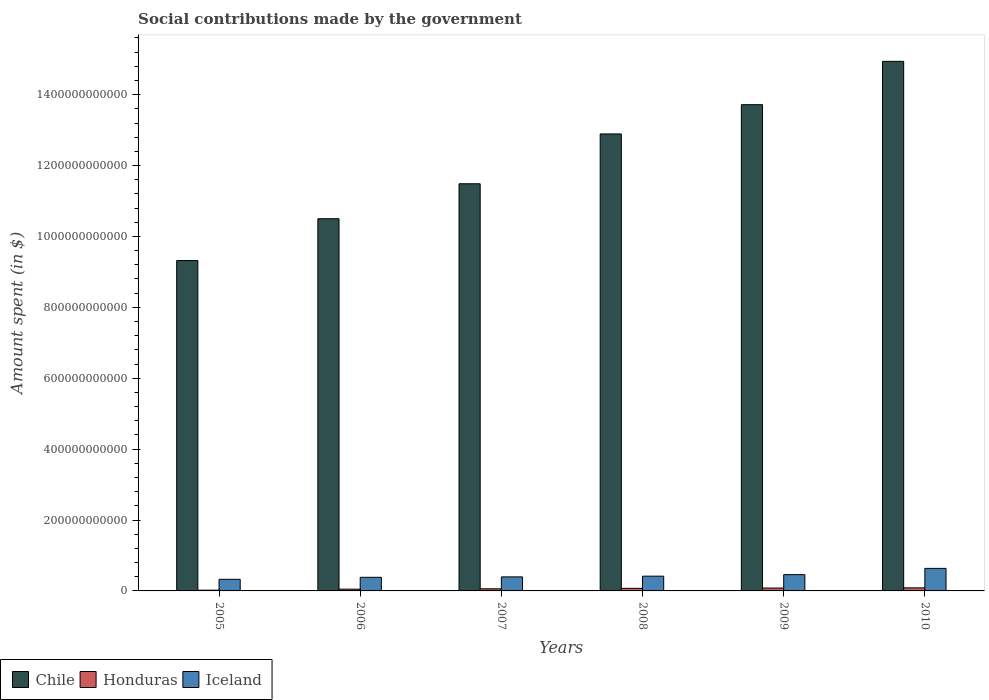How many different coloured bars are there?
Your answer should be very brief. 3. Are the number of bars per tick equal to the number of legend labels?
Provide a succinct answer. Yes. Are the number of bars on each tick of the X-axis equal?
Your answer should be very brief. Yes. How many bars are there on the 3rd tick from the left?
Keep it short and to the point. 3. In how many cases, is the number of bars for a given year not equal to the number of legend labels?
Provide a succinct answer. 0. What is the amount spent on social contributions in Honduras in 2005?
Give a very brief answer. 2.13e+09. Across all years, what is the maximum amount spent on social contributions in Honduras?
Your answer should be compact. 8.67e+09. Across all years, what is the minimum amount spent on social contributions in Iceland?
Provide a short and direct response. 3.28e+1. What is the total amount spent on social contributions in Iceland in the graph?
Provide a short and direct response. 2.62e+11. What is the difference between the amount spent on social contributions in Iceland in 2008 and that in 2010?
Make the answer very short. -2.20e+1. What is the difference between the amount spent on social contributions in Chile in 2008 and the amount spent on social contributions in Honduras in 2006?
Give a very brief answer. 1.28e+12. What is the average amount spent on social contributions in Honduras per year?
Your response must be concise. 6.20e+09. In the year 2009, what is the difference between the amount spent on social contributions in Iceland and amount spent on social contributions in Chile?
Provide a succinct answer. -1.33e+12. In how many years, is the amount spent on social contributions in Honduras greater than 240000000000 $?
Your response must be concise. 0. What is the ratio of the amount spent on social contributions in Honduras in 2007 to that in 2009?
Keep it short and to the point. 0.74. Is the amount spent on social contributions in Iceland in 2008 less than that in 2010?
Make the answer very short. Yes. Is the difference between the amount spent on social contributions in Iceland in 2006 and 2008 greater than the difference between the amount spent on social contributions in Chile in 2006 and 2008?
Your answer should be compact. Yes. What is the difference between the highest and the second highest amount spent on social contributions in Honduras?
Ensure brevity in your answer.  5.49e+08. What is the difference between the highest and the lowest amount spent on social contributions in Iceland?
Ensure brevity in your answer.  3.08e+1. In how many years, is the amount spent on social contributions in Iceland greater than the average amount spent on social contributions in Iceland taken over all years?
Offer a very short reply. 2. Is the sum of the amount spent on social contributions in Iceland in 2007 and 2008 greater than the maximum amount spent on social contributions in Chile across all years?
Provide a short and direct response. No. What is the difference between two consecutive major ticks on the Y-axis?
Your answer should be very brief. 2.00e+11. Are the values on the major ticks of Y-axis written in scientific E-notation?
Offer a very short reply. No. Does the graph contain any zero values?
Your response must be concise. No. Does the graph contain grids?
Give a very brief answer. No. How are the legend labels stacked?
Your answer should be very brief. Horizontal. What is the title of the graph?
Keep it short and to the point. Social contributions made by the government. Does "Armenia" appear as one of the legend labels in the graph?
Make the answer very short. No. What is the label or title of the X-axis?
Offer a very short reply. Years. What is the label or title of the Y-axis?
Offer a very short reply. Amount spent (in $). What is the Amount spent (in $) of Chile in 2005?
Give a very brief answer. 9.32e+11. What is the Amount spent (in $) in Honduras in 2005?
Your response must be concise. 2.13e+09. What is the Amount spent (in $) of Iceland in 2005?
Make the answer very short. 3.28e+1. What is the Amount spent (in $) in Chile in 2006?
Your answer should be very brief. 1.05e+12. What is the Amount spent (in $) in Honduras in 2006?
Ensure brevity in your answer.  4.96e+09. What is the Amount spent (in $) in Iceland in 2006?
Your response must be concise. 3.84e+1. What is the Amount spent (in $) of Chile in 2007?
Your answer should be compact. 1.15e+12. What is the Amount spent (in $) in Honduras in 2007?
Provide a short and direct response. 6.04e+09. What is the Amount spent (in $) in Iceland in 2007?
Offer a terse response. 3.96e+1. What is the Amount spent (in $) of Chile in 2008?
Offer a terse response. 1.29e+12. What is the Amount spent (in $) of Honduras in 2008?
Offer a very short reply. 7.31e+09. What is the Amount spent (in $) in Iceland in 2008?
Offer a very short reply. 4.16e+1. What is the Amount spent (in $) in Chile in 2009?
Give a very brief answer. 1.37e+12. What is the Amount spent (in $) of Honduras in 2009?
Keep it short and to the point. 8.12e+09. What is the Amount spent (in $) of Iceland in 2009?
Your answer should be compact. 4.59e+1. What is the Amount spent (in $) of Chile in 2010?
Offer a very short reply. 1.49e+12. What is the Amount spent (in $) in Honduras in 2010?
Your response must be concise. 8.67e+09. What is the Amount spent (in $) of Iceland in 2010?
Your response must be concise. 6.36e+1. Across all years, what is the maximum Amount spent (in $) in Chile?
Offer a terse response. 1.49e+12. Across all years, what is the maximum Amount spent (in $) in Honduras?
Offer a terse response. 8.67e+09. Across all years, what is the maximum Amount spent (in $) in Iceland?
Make the answer very short. 6.36e+1. Across all years, what is the minimum Amount spent (in $) in Chile?
Ensure brevity in your answer.  9.32e+11. Across all years, what is the minimum Amount spent (in $) of Honduras?
Provide a succinct answer. 2.13e+09. Across all years, what is the minimum Amount spent (in $) of Iceland?
Make the answer very short. 3.28e+1. What is the total Amount spent (in $) of Chile in the graph?
Make the answer very short. 7.29e+12. What is the total Amount spent (in $) in Honduras in the graph?
Your answer should be compact. 3.72e+1. What is the total Amount spent (in $) of Iceland in the graph?
Offer a terse response. 2.62e+11. What is the difference between the Amount spent (in $) of Chile in 2005 and that in 2006?
Your answer should be very brief. -1.18e+11. What is the difference between the Amount spent (in $) of Honduras in 2005 and that in 2006?
Offer a terse response. -2.83e+09. What is the difference between the Amount spent (in $) in Iceland in 2005 and that in 2006?
Provide a succinct answer. -5.64e+09. What is the difference between the Amount spent (in $) of Chile in 2005 and that in 2007?
Ensure brevity in your answer.  -2.17e+11. What is the difference between the Amount spent (in $) in Honduras in 2005 and that in 2007?
Make the answer very short. -3.91e+09. What is the difference between the Amount spent (in $) in Iceland in 2005 and that in 2007?
Keep it short and to the point. -6.82e+09. What is the difference between the Amount spent (in $) in Chile in 2005 and that in 2008?
Offer a terse response. -3.57e+11. What is the difference between the Amount spent (in $) of Honduras in 2005 and that in 2008?
Provide a succinct answer. -5.18e+09. What is the difference between the Amount spent (in $) of Iceland in 2005 and that in 2008?
Give a very brief answer. -8.87e+09. What is the difference between the Amount spent (in $) of Chile in 2005 and that in 2009?
Provide a succinct answer. -4.40e+11. What is the difference between the Amount spent (in $) in Honduras in 2005 and that in 2009?
Your answer should be very brief. -5.99e+09. What is the difference between the Amount spent (in $) of Iceland in 2005 and that in 2009?
Keep it short and to the point. -1.31e+1. What is the difference between the Amount spent (in $) in Chile in 2005 and that in 2010?
Make the answer very short. -5.62e+11. What is the difference between the Amount spent (in $) of Honduras in 2005 and that in 2010?
Ensure brevity in your answer.  -6.54e+09. What is the difference between the Amount spent (in $) in Iceland in 2005 and that in 2010?
Offer a terse response. -3.08e+1. What is the difference between the Amount spent (in $) in Chile in 2006 and that in 2007?
Offer a terse response. -9.86e+1. What is the difference between the Amount spent (in $) of Honduras in 2006 and that in 2007?
Ensure brevity in your answer.  -1.08e+09. What is the difference between the Amount spent (in $) in Iceland in 2006 and that in 2007?
Provide a short and direct response. -1.18e+09. What is the difference between the Amount spent (in $) in Chile in 2006 and that in 2008?
Your response must be concise. -2.39e+11. What is the difference between the Amount spent (in $) of Honduras in 2006 and that in 2008?
Provide a succinct answer. -2.35e+09. What is the difference between the Amount spent (in $) in Iceland in 2006 and that in 2008?
Offer a terse response. -3.23e+09. What is the difference between the Amount spent (in $) of Chile in 2006 and that in 2009?
Keep it short and to the point. -3.22e+11. What is the difference between the Amount spent (in $) of Honduras in 2006 and that in 2009?
Keep it short and to the point. -3.16e+09. What is the difference between the Amount spent (in $) of Iceland in 2006 and that in 2009?
Ensure brevity in your answer.  -7.50e+09. What is the difference between the Amount spent (in $) in Chile in 2006 and that in 2010?
Offer a very short reply. -4.44e+11. What is the difference between the Amount spent (in $) of Honduras in 2006 and that in 2010?
Provide a short and direct response. -3.71e+09. What is the difference between the Amount spent (in $) of Iceland in 2006 and that in 2010?
Provide a short and direct response. -2.52e+1. What is the difference between the Amount spent (in $) in Chile in 2007 and that in 2008?
Your response must be concise. -1.41e+11. What is the difference between the Amount spent (in $) in Honduras in 2007 and that in 2008?
Provide a succinct answer. -1.27e+09. What is the difference between the Amount spent (in $) in Iceland in 2007 and that in 2008?
Make the answer very short. -2.05e+09. What is the difference between the Amount spent (in $) of Chile in 2007 and that in 2009?
Make the answer very short. -2.23e+11. What is the difference between the Amount spent (in $) of Honduras in 2007 and that in 2009?
Provide a succinct answer. -2.09e+09. What is the difference between the Amount spent (in $) of Iceland in 2007 and that in 2009?
Provide a succinct answer. -6.32e+09. What is the difference between the Amount spent (in $) in Chile in 2007 and that in 2010?
Your response must be concise. -3.45e+11. What is the difference between the Amount spent (in $) of Honduras in 2007 and that in 2010?
Your answer should be compact. -2.63e+09. What is the difference between the Amount spent (in $) in Iceland in 2007 and that in 2010?
Your answer should be compact. -2.40e+1. What is the difference between the Amount spent (in $) of Chile in 2008 and that in 2009?
Provide a short and direct response. -8.25e+1. What is the difference between the Amount spent (in $) in Honduras in 2008 and that in 2009?
Provide a short and direct response. -8.14e+08. What is the difference between the Amount spent (in $) of Iceland in 2008 and that in 2009?
Your answer should be compact. -4.27e+09. What is the difference between the Amount spent (in $) of Chile in 2008 and that in 2010?
Offer a very short reply. -2.05e+11. What is the difference between the Amount spent (in $) of Honduras in 2008 and that in 2010?
Keep it short and to the point. -1.36e+09. What is the difference between the Amount spent (in $) of Iceland in 2008 and that in 2010?
Make the answer very short. -2.20e+1. What is the difference between the Amount spent (in $) of Chile in 2009 and that in 2010?
Ensure brevity in your answer.  -1.22e+11. What is the difference between the Amount spent (in $) in Honduras in 2009 and that in 2010?
Offer a very short reply. -5.49e+08. What is the difference between the Amount spent (in $) of Iceland in 2009 and that in 2010?
Ensure brevity in your answer.  -1.77e+1. What is the difference between the Amount spent (in $) in Chile in 2005 and the Amount spent (in $) in Honduras in 2006?
Your response must be concise. 9.27e+11. What is the difference between the Amount spent (in $) in Chile in 2005 and the Amount spent (in $) in Iceland in 2006?
Ensure brevity in your answer.  8.94e+11. What is the difference between the Amount spent (in $) in Honduras in 2005 and the Amount spent (in $) in Iceland in 2006?
Your answer should be very brief. -3.63e+1. What is the difference between the Amount spent (in $) in Chile in 2005 and the Amount spent (in $) in Honduras in 2007?
Make the answer very short. 9.26e+11. What is the difference between the Amount spent (in $) in Chile in 2005 and the Amount spent (in $) in Iceland in 2007?
Provide a succinct answer. 8.92e+11. What is the difference between the Amount spent (in $) in Honduras in 2005 and the Amount spent (in $) in Iceland in 2007?
Your answer should be very brief. -3.75e+1. What is the difference between the Amount spent (in $) in Chile in 2005 and the Amount spent (in $) in Honduras in 2008?
Give a very brief answer. 9.25e+11. What is the difference between the Amount spent (in $) of Chile in 2005 and the Amount spent (in $) of Iceland in 2008?
Offer a very short reply. 8.90e+11. What is the difference between the Amount spent (in $) of Honduras in 2005 and the Amount spent (in $) of Iceland in 2008?
Provide a succinct answer. -3.95e+1. What is the difference between the Amount spent (in $) in Chile in 2005 and the Amount spent (in $) in Honduras in 2009?
Give a very brief answer. 9.24e+11. What is the difference between the Amount spent (in $) in Chile in 2005 and the Amount spent (in $) in Iceland in 2009?
Your answer should be compact. 8.86e+11. What is the difference between the Amount spent (in $) of Honduras in 2005 and the Amount spent (in $) of Iceland in 2009?
Offer a very short reply. -4.38e+1. What is the difference between the Amount spent (in $) of Chile in 2005 and the Amount spent (in $) of Honduras in 2010?
Ensure brevity in your answer.  9.23e+11. What is the difference between the Amount spent (in $) of Chile in 2005 and the Amount spent (in $) of Iceland in 2010?
Provide a short and direct response. 8.68e+11. What is the difference between the Amount spent (in $) in Honduras in 2005 and the Amount spent (in $) in Iceland in 2010?
Offer a terse response. -6.15e+1. What is the difference between the Amount spent (in $) of Chile in 2006 and the Amount spent (in $) of Honduras in 2007?
Ensure brevity in your answer.  1.04e+12. What is the difference between the Amount spent (in $) in Chile in 2006 and the Amount spent (in $) in Iceland in 2007?
Your response must be concise. 1.01e+12. What is the difference between the Amount spent (in $) in Honduras in 2006 and the Amount spent (in $) in Iceland in 2007?
Keep it short and to the point. -3.46e+1. What is the difference between the Amount spent (in $) in Chile in 2006 and the Amount spent (in $) in Honduras in 2008?
Provide a succinct answer. 1.04e+12. What is the difference between the Amount spent (in $) of Chile in 2006 and the Amount spent (in $) of Iceland in 2008?
Give a very brief answer. 1.01e+12. What is the difference between the Amount spent (in $) of Honduras in 2006 and the Amount spent (in $) of Iceland in 2008?
Your answer should be very brief. -3.67e+1. What is the difference between the Amount spent (in $) in Chile in 2006 and the Amount spent (in $) in Honduras in 2009?
Ensure brevity in your answer.  1.04e+12. What is the difference between the Amount spent (in $) in Chile in 2006 and the Amount spent (in $) in Iceland in 2009?
Provide a short and direct response. 1.00e+12. What is the difference between the Amount spent (in $) in Honduras in 2006 and the Amount spent (in $) in Iceland in 2009?
Offer a very short reply. -4.10e+1. What is the difference between the Amount spent (in $) of Chile in 2006 and the Amount spent (in $) of Honduras in 2010?
Offer a terse response. 1.04e+12. What is the difference between the Amount spent (in $) in Chile in 2006 and the Amount spent (in $) in Iceland in 2010?
Your answer should be very brief. 9.86e+11. What is the difference between the Amount spent (in $) of Honduras in 2006 and the Amount spent (in $) of Iceland in 2010?
Your response must be concise. -5.86e+1. What is the difference between the Amount spent (in $) of Chile in 2007 and the Amount spent (in $) of Honduras in 2008?
Offer a terse response. 1.14e+12. What is the difference between the Amount spent (in $) in Chile in 2007 and the Amount spent (in $) in Iceland in 2008?
Your answer should be very brief. 1.11e+12. What is the difference between the Amount spent (in $) in Honduras in 2007 and the Amount spent (in $) in Iceland in 2008?
Provide a short and direct response. -3.56e+1. What is the difference between the Amount spent (in $) of Chile in 2007 and the Amount spent (in $) of Honduras in 2009?
Offer a very short reply. 1.14e+12. What is the difference between the Amount spent (in $) in Chile in 2007 and the Amount spent (in $) in Iceland in 2009?
Provide a succinct answer. 1.10e+12. What is the difference between the Amount spent (in $) of Honduras in 2007 and the Amount spent (in $) of Iceland in 2009?
Make the answer very short. -3.99e+1. What is the difference between the Amount spent (in $) in Chile in 2007 and the Amount spent (in $) in Honduras in 2010?
Keep it short and to the point. 1.14e+12. What is the difference between the Amount spent (in $) in Chile in 2007 and the Amount spent (in $) in Iceland in 2010?
Your answer should be very brief. 1.09e+12. What is the difference between the Amount spent (in $) of Honduras in 2007 and the Amount spent (in $) of Iceland in 2010?
Provide a succinct answer. -5.76e+1. What is the difference between the Amount spent (in $) in Chile in 2008 and the Amount spent (in $) in Honduras in 2009?
Your answer should be compact. 1.28e+12. What is the difference between the Amount spent (in $) of Chile in 2008 and the Amount spent (in $) of Iceland in 2009?
Make the answer very short. 1.24e+12. What is the difference between the Amount spent (in $) in Honduras in 2008 and the Amount spent (in $) in Iceland in 2009?
Offer a very short reply. -3.86e+1. What is the difference between the Amount spent (in $) of Chile in 2008 and the Amount spent (in $) of Honduras in 2010?
Ensure brevity in your answer.  1.28e+12. What is the difference between the Amount spent (in $) in Chile in 2008 and the Amount spent (in $) in Iceland in 2010?
Give a very brief answer. 1.23e+12. What is the difference between the Amount spent (in $) in Honduras in 2008 and the Amount spent (in $) in Iceland in 2010?
Ensure brevity in your answer.  -5.63e+1. What is the difference between the Amount spent (in $) of Chile in 2009 and the Amount spent (in $) of Honduras in 2010?
Your answer should be very brief. 1.36e+12. What is the difference between the Amount spent (in $) in Chile in 2009 and the Amount spent (in $) in Iceland in 2010?
Provide a short and direct response. 1.31e+12. What is the difference between the Amount spent (in $) in Honduras in 2009 and the Amount spent (in $) in Iceland in 2010?
Ensure brevity in your answer.  -5.55e+1. What is the average Amount spent (in $) in Chile per year?
Your answer should be compact. 1.21e+12. What is the average Amount spent (in $) in Honduras per year?
Your answer should be very brief. 6.20e+09. What is the average Amount spent (in $) of Iceland per year?
Give a very brief answer. 4.37e+1. In the year 2005, what is the difference between the Amount spent (in $) in Chile and Amount spent (in $) in Honduras?
Provide a short and direct response. 9.30e+11. In the year 2005, what is the difference between the Amount spent (in $) in Chile and Amount spent (in $) in Iceland?
Your answer should be compact. 8.99e+11. In the year 2005, what is the difference between the Amount spent (in $) in Honduras and Amount spent (in $) in Iceland?
Give a very brief answer. -3.06e+1. In the year 2006, what is the difference between the Amount spent (in $) of Chile and Amount spent (in $) of Honduras?
Provide a short and direct response. 1.05e+12. In the year 2006, what is the difference between the Amount spent (in $) in Chile and Amount spent (in $) in Iceland?
Provide a succinct answer. 1.01e+12. In the year 2006, what is the difference between the Amount spent (in $) of Honduras and Amount spent (in $) of Iceland?
Ensure brevity in your answer.  -3.35e+1. In the year 2007, what is the difference between the Amount spent (in $) in Chile and Amount spent (in $) in Honduras?
Provide a short and direct response. 1.14e+12. In the year 2007, what is the difference between the Amount spent (in $) of Chile and Amount spent (in $) of Iceland?
Give a very brief answer. 1.11e+12. In the year 2007, what is the difference between the Amount spent (in $) of Honduras and Amount spent (in $) of Iceland?
Your response must be concise. -3.36e+1. In the year 2008, what is the difference between the Amount spent (in $) of Chile and Amount spent (in $) of Honduras?
Provide a short and direct response. 1.28e+12. In the year 2008, what is the difference between the Amount spent (in $) of Chile and Amount spent (in $) of Iceland?
Offer a terse response. 1.25e+12. In the year 2008, what is the difference between the Amount spent (in $) of Honduras and Amount spent (in $) of Iceland?
Offer a very short reply. -3.43e+1. In the year 2009, what is the difference between the Amount spent (in $) of Chile and Amount spent (in $) of Honduras?
Your answer should be compact. 1.36e+12. In the year 2009, what is the difference between the Amount spent (in $) in Chile and Amount spent (in $) in Iceland?
Ensure brevity in your answer.  1.33e+12. In the year 2009, what is the difference between the Amount spent (in $) of Honduras and Amount spent (in $) of Iceland?
Provide a succinct answer. -3.78e+1. In the year 2010, what is the difference between the Amount spent (in $) in Chile and Amount spent (in $) in Honduras?
Your response must be concise. 1.49e+12. In the year 2010, what is the difference between the Amount spent (in $) in Chile and Amount spent (in $) in Iceland?
Your response must be concise. 1.43e+12. In the year 2010, what is the difference between the Amount spent (in $) in Honduras and Amount spent (in $) in Iceland?
Your response must be concise. -5.49e+1. What is the ratio of the Amount spent (in $) of Chile in 2005 to that in 2006?
Ensure brevity in your answer.  0.89. What is the ratio of the Amount spent (in $) of Honduras in 2005 to that in 2006?
Provide a short and direct response. 0.43. What is the ratio of the Amount spent (in $) of Iceland in 2005 to that in 2006?
Ensure brevity in your answer.  0.85. What is the ratio of the Amount spent (in $) in Chile in 2005 to that in 2007?
Offer a terse response. 0.81. What is the ratio of the Amount spent (in $) of Honduras in 2005 to that in 2007?
Your answer should be very brief. 0.35. What is the ratio of the Amount spent (in $) of Iceland in 2005 to that in 2007?
Give a very brief answer. 0.83. What is the ratio of the Amount spent (in $) in Chile in 2005 to that in 2008?
Ensure brevity in your answer.  0.72. What is the ratio of the Amount spent (in $) in Honduras in 2005 to that in 2008?
Give a very brief answer. 0.29. What is the ratio of the Amount spent (in $) in Iceland in 2005 to that in 2008?
Provide a short and direct response. 0.79. What is the ratio of the Amount spent (in $) of Chile in 2005 to that in 2009?
Your response must be concise. 0.68. What is the ratio of the Amount spent (in $) in Honduras in 2005 to that in 2009?
Your answer should be compact. 0.26. What is the ratio of the Amount spent (in $) of Iceland in 2005 to that in 2009?
Ensure brevity in your answer.  0.71. What is the ratio of the Amount spent (in $) of Chile in 2005 to that in 2010?
Your answer should be very brief. 0.62. What is the ratio of the Amount spent (in $) of Honduras in 2005 to that in 2010?
Offer a terse response. 0.25. What is the ratio of the Amount spent (in $) of Iceland in 2005 to that in 2010?
Provide a short and direct response. 0.52. What is the ratio of the Amount spent (in $) in Chile in 2006 to that in 2007?
Your answer should be very brief. 0.91. What is the ratio of the Amount spent (in $) of Honduras in 2006 to that in 2007?
Your answer should be compact. 0.82. What is the ratio of the Amount spent (in $) of Iceland in 2006 to that in 2007?
Make the answer very short. 0.97. What is the ratio of the Amount spent (in $) of Chile in 2006 to that in 2008?
Ensure brevity in your answer.  0.81. What is the ratio of the Amount spent (in $) in Honduras in 2006 to that in 2008?
Provide a succinct answer. 0.68. What is the ratio of the Amount spent (in $) in Iceland in 2006 to that in 2008?
Provide a succinct answer. 0.92. What is the ratio of the Amount spent (in $) of Chile in 2006 to that in 2009?
Your response must be concise. 0.77. What is the ratio of the Amount spent (in $) of Honduras in 2006 to that in 2009?
Keep it short and to the point. 0.61. What is the ratio of the Amount spent (in $) in Iceland in 2006 to that in 2009?
Provide a short and direct response. 0.84. What is the ratio of the Amount spent (in $) of Chile in 2006 to that in 2010?
Provide a short and direct response. 0.7. What is the ratio of the Amount spent (in $) in Honduras in 2006 to that in 2010?
Offer a very short reply. 0.57. What is the ratio of the Amount spent (in $) in Iceland in 2006 to that in 2010?
Give a very brief answer. 0.6. What is the ratio of the Amount spent (in $) of Chile in 2007 to that in 2008?
Your answer should be very brief. 0.89. What is the ratio of the Amount spent (in $) of Honduras in 2007 to that in 2008?
Provide a succinct answer. 0.83. What is the ratio of the Amount spent (in $) in Iceland in 2007 to that in 2008?
Make the answer very short. 0.95. What is the ratio of the Amount spent (in $) of Chile in 2007 to that in 2009?
Provide a succinct answer. 0.84. What is the ratio of the Amount spent (in $) of Honduras in 2007 to that in 2009?
Your response must be concise. 0.74. What is the ratio of the Amount spent (in $) in Iceland in 2007 to that in 2009?
Your answer should be compact. 0.86. What is the ratio of the Amount spent (in $) in Chile in 2007 to that in 2010?
Give a very brief answer. 0.77. What is the ratio of the Amount spent (in $) of Honduras in 2007 to that in 2010?
Offer a terse response. 0.7. What is the ratio of the Amount spent (in $) of Iceland in 2007 to that in 2010?
Your response must be concise. 0.62. What is the ratio of the Amount spent (in $) in Chile in 2008 to that in 2009?
Keep it short and to the point. 0.94. What is the ratio of the Amount spent (in $) in Honduras in 2008 to that in 2009?
Make the answer very short. 0.9. What is the ratio of the Amount spent (in $) of Iceland in 2008 to that in 2009?
Ensure brevity in your answer.  0.91. What is the ratio of the Amount spent (in $) of Chile in 2008 to that in 2010?
Ensure brevity in your answer.  0.86. What is the ratio of the Amount spent (in $) in Honduras in 2008 to that in 2010?
Make the answer very short. 0.84. What is the ratio of the Amount spent (in $) of Iceland in 2008 to that in 2010?
Keep it short and to the point. 0.65. What is the ratio of the Amount spent (in $) in Chile in 2009 to that in 2010?
Make the answer very short. 0.92. What is the ratio of the Amount spent (in $) of Honduras in 2009 to that in 2010?
Keep it short and to the point. 0.94. What is the ratio of the Amount spent (in $) of Iceland in 2009 to that in 2010?
Provide a short and direct response. 0.72. What is the difference between the highest and the second highest Amount spent (in $) in Chile?
Your answer should be compact. 1.22e+11. What is the difference between the highest and the second highest Amount spent (in $) of Honduras?
Offer a very short reply. 5.49e+08. What is the difference between the highest and the second highest Amount spent (in $) of Iceland?
Provide a succinct answer. 1.77e+1. What is the difference between the highest and the lowest Amount spent (in $) of Chile?
Keep it short and to the point. 5.62e+11. What is the difference between the highest and the lowest Amount spent (in $) of Honduras?
Give a very brief answer. 6.54e+09. What is the difference between the highest and the lowest Amount spent (in $) of Iceland?
Ensure brevity in your answer.  3.08e+1. 